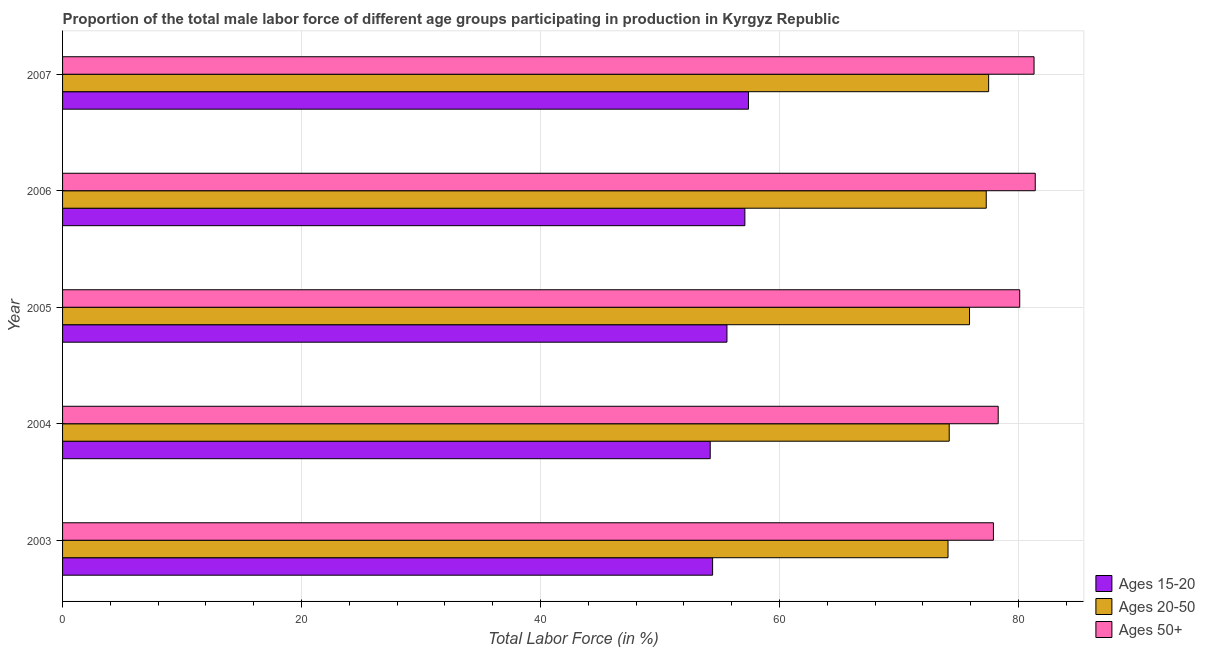How many bars are there on the 3rd tick from the top?
Ensure brevity in your answer.  3. How many bars are there on the 3rd tick from the bottom?
Your answer should be compact. 3. What is the percentage of male labor force within the age group 15-20 in 2007?
Make the answer very short. 57.4. Across all years, what is the maximum percentage of male labor force within the age group 20-50?
Your answer should be very brief. 77.5. Across all years, what is the minimum percentage of male labor force within the age group 20-50?
Offer a terse response. 74.1. In which year was the percentage of male labor force within the age group 20-50 minimum?
Provide a succinct answer. 2003. What is the total percentage of male labor force above age 50 in the graph?
Give a very brief answer. 399. What is the difference between the percentage of male labor force within the age group 20-50 in 2006 and that in 2007?
Offer a terse response. -0.2. What is the difference between the percentage of male labor force within the age group 20-50 in 2006 and the percentage of male labor force within the age group 15-20 in 2003?
Give a very brief answer. 22.9. What is the average percentage of male labor force within the age group 15-20 per year?
Your answer should be compact. 55.74. In the year 2006, what is the difference between the percentage of male labor force within the age group 15-20 and percentage of male labor force within the age group 20-50?
Offer a very short reply. -20.2. In how many years, is the percentage of male labor force within the age group 20-50 greater than 60 %?
Provide a succinct answer. 5. Is the difference between the percentage of male labor force within the age group 20-50 in 2003 and 2007 greater than the difference between the percentage of male labor force above age 50 in 2003 and 2007?
Give a very brief answer. No. What is the difference between the highest and the lowest percentage of male labor force within the age group 20-50?
Give a very brief answer. 3.4. Is the sum of the percentage of male labor force above age 50 in 2006 and 2007 greater than the maximum percentage of male labor force within the age group 20-50 across all years?
Your answer should be compact. Yes. What does the 3rd bar from the top in 2004 represents?
Make the answer very short. Ages 15-20. What does the 1st bar from the bottom in 2005 represents?
Give a very brief answer. Ages 15-20. How many bars are there?
Offer a very short reply. 15. How many years are there in the graph?
Offer a very short reply. 5. Does the graph contain any zero values?
Make the answer very short. No. What is the title of the graph?
Offer a terse response. Proportion of the total male labor force of different age groups participating in production in Kyrgyz Republic. What is the Total Labor Force (in %) in Ages 15-20 in 2003?
Keep it short and to the point. 54.4. What is the Total Labor Force (in %) of Ages 20-50 in 2003?
Provide a short and direct response. 74.1. What is the Total Labor Force (in %) of Ages 50+ in 2003?
Ensure brevity in your answer.  77.9. What is the Total Labor Force (in %) of Ages 15-20 in 2004?
Make the answer very short. 54.2. What is the Total Labor Force (in %) of Ages 20-50 in 2004?
Provide a short and direct response. 74.2. What is the Total Labor Force (in %) of Ages 50+ in 2004?
Give a very brief answer. 78.3. What is the Total Labor Force (in %) of Ages 15-20 in 2005?
Your answer should be very brief. 55.6. What is the Total Labor Force (in %) in Ages 20-50 in 2005?
Keep it short and to the point. 75.9. What is the Total Labor Force (in %) of Ages 50+ in 2005?
Provide a succinct answer. 80.1. What is the Total Labor Force (in %) in Ages 15-20 in 2006?
Make the answer very short. 57.1. What is the Total Labor Force (in %) in Ages 20-50 in 2006?
Give a very brief answer. 77.3. What is the Total Labor Force (in %) of Ages 50+ in 2006?
Provide a short and direct response. 81.4. What is the Total Labor Force (in %) in Ages 15-20 in 2007?
Make the answer very short. 57.4. What is the Total Labor Force (in %) in Ages 20-50 in 2007?
Your response must be concise. 77.5. What is the Total Labor Force (in %) of Ages 50+ in 2007?
Offer a very short reply. 81.3. Across all years, what is the maximum Total Labor Force (in %) of Ages 15-20?
Your answer should be very brief. 57.4. Across all years, what is the maximum Total Labor Force (in %) in Ages 20-50?
Make the answer very short. 77.5. Across all years, what is the maximum Total Labor Force (in %) of Ages 50+?
Ensure brevity in your answer.  81.4. Across all years, what is the minimum Total Labor Force (in %) of Ages 15-20?
Make the answer very short. 54.2. Across all years, what is the minimum Total Labor Force (in %) in Ages 20-50?
Provide a succinct answer. 74.1. Across all years, what is the minimum Total Labor Force (in %) in Ages 50+?
Ensure brevity in your answer.  77.9. What is the total Total Labor Force (in %) in Ages 15-20 in the graph?
Give a very brief answer. 278.7. What is the total Total Labor Force (in %) of Ages 20-50 in the graph?
Ensure brevity in your answer.  379. What is the total Total Labor Force (in %) in Ages 50+ in the graph?
Your answer should be compact. 399. What is the difference between the Total Labor Force (in %) of Ages 20-50 in 2003 and that in 2005?
Give a very brief answer. -1.8. What is the difference between the Total Labor Force (in %) of Ages 20-50 in 2003 and that in 2006?
Your answer should be compact. -3.2. What is the difference between the Total Labor Force (in %) in Ages 20-50 in 2003 and that in 2007?
Offer a terse response. -3.4. What is the difference between the Total Labor Force (in %) of Ages 50+ in 2004 and that in 2005?
Your answer should be very brief. -1.8. What is the difference between the Total Labor Force (in %) of Ages 15-20 in 2004 and that in 2006?
Offer a terse response. -2.9. What is the difference between the Total Labor Force (in %) of Ages 50+ in 2004 and that in 2006?
Offer a terse response. -3.1. What is the difference between the Total Labor Force (in %) of Ages 15-20 in 2005 and that in 2006?
Provide a short and direct response. -1.5. What is the difference between the Total Labor Force (in %) of Ages 20-50 in 2005 and that in 2006?
Your answer should be very brief. -1.4. What is the difference between the Total Labor Force (in %) in Ages 50+ in 2005 and that in 2006?
Keep it short and to the point. -1.3. What is the difference between the Total Labor Force (in %) of Ages 20-50 in 2005 and that in 2007?
Your answer should be very brief. -1.6. What is the difference between the Total Labor Force (in %) in Ages 20-50 in 2006 and that in 2007?
Ensure brevity in your answer.  -0.2. What is the difference between the Total Labor Force (in %) of Ages 15-20 in 2003 and the Total Labor Force (in %) of Ages 20-50 in 2004?
Ensure brevity in your answer.  -19.8. What is the difference between the Total Labor Force (in %) of Ages 15-20 in 2003 and the Total Labor Force (in %) of Ages 50+ in 2004?
Your response must be concise. -23.9. What is the difference between the Total Labor Force (in %) of Ages 20-50 in 2003 and the Total Labor Force (in %) of Ages 50+ in 2004?
Offer a terse response. -4.2. What is the difference between the Total Labor Force (in %) in Ages 15-20 in 2003 and the Total Labor Force (in %) in Ages 20-50 in 2005?
Ensure brevity in your answer.  -21.5. What is the difference between the Total Labor Force (in %) in Ages 15-20 in 2003 and the Total Labor Force (in %) in Ages 50+ in 2005?
Keep it short and to the point. -25.7. What is the difference between the Total Labor Force (in %) in Ages 20-50 in 2003 and the Total Labor Force (in %) in Ages 50+ in 2005?
Ensure brevity in your answer.  -6. What is the difference between the Total Labor Force (in %) of Ages 15-20 in 2003 and the Total Labor Force (in %) of Ages 20-50 in 2006?
Make the answer very short. -22.9. What is the difference between the Total Labor Force (in %) of Ages 15-20 in 2003 and the Total Labor Force (in %) of Ages 20-50 in 2007?
Your response must be concise. -23.1. What is the difference between the Total Labor Force (in %) of Ages 15-20 in 2003 and the Total Labor Force (in %) of Ages 50+ in 2007?
Provide a succinct answer. -26.9. What is the difference between the Total Labor Force (in %) in Ages 20-50 in 2003 and the Total Labor Force (in %) in Ages 50+ in 2007?
Provide a short and direct response. -7.2. What is the difference between the Total Labor Force (in %) in Ages 15-20 in 2004 and the Total Labor Force (in %) in Ages 20-50 in 2005?
Ensure brevity in your answer.  -21.7. What is the difference between the Total Labor Force (in %) of Ages 15-20 in 2004 and the Total Labor Force (in %) of Ages 50+ in 2005?
Ensure brevity in your answer.  -25.9. What is the difference between the Total Labor Force (in %) of Ages 15-20 in 2004 and the Total Labor Force (in %) of Ages 20-50 in 2006?
Your response must be concise. -23.1. What is the difference between the Total Labor Force (in %) of Ages 15-20 in 2004 and the Total Labor Force (in %) of Ages 50+ in 2006?
Your answer should be compact. -27.2. What is the difference between the Total Labor Force (in %) in Ages 20-50 in 2004 and the Total Labor Force (in %) in Ages 50+ in 2006?
Give a very brief answer. -7.2. What is the difference between the Total Labor Force (in %) in Ages 15-20 in 2004 and the Total Labor Force (in %) in Ages 20-50 in 2007?
Offer a very short reply. -23.3. What is the difference between the Total Labor Force (in %) of Ages 15-20 in 2004 and the Total Labor Force (in %) of Ages 50+ in 2007?
Ensure brevity in your answer.  -27.1. What is the difference between the Total Labor Force (in %) in Ages 15-20 in 2005 and the Total Labor Force (in %) in Ages 20-50 in 2006?
Provide a short and direct response. -21.7. What is the difference between the Total Labor Force (in %) of Ages 15-20 in 2005 and the Total Labor Force (in %) of Ages 50+ in 2006?
Provide a succinct answer. -25.8. What is the difference between the Total Labor Force (in %) of Ages 20-50 in 2005 and the Total Labor Force (in %) of Ages 50+ in 2006?
Your answer should be compact. -5.5. What is the difference between the Total Labor Force (in %) in Ages 15-20 in 2005 and the Total Labor Force (in %) in Ages 20-50 in 2007?
Provide a short and direct response. -21.9. What is the difference between the Total Labor Force (in %) in Ages 15-20 in 2005 and the Total Labor Force (in %) in Ages 50+ in 2007?
Your answer should be compact. -25.7. What is the difference between the Total Labor Force (in %) in Ages 15-20 in 2006 and the Total Labor Force (in %) in Ages 20-50 in 2007?
Offer a very short reply. -20.4. What is the difference between the Total Labor Force (in %) in Ages 15-20 in 2006 and the Total Labor Force (in %) in Ages 50+ in 2007?
Your answer should be compact. -24.2. What is the difference between the Total Labor Force (in %) of Ages 20-50 in 2006 and the Total Labor Force (in %) of Ages 50+ in 2007?
Provide a short and direct response. -4. What is the average Total Labor Force (in %) in Ages 15-20 per year?
Provide a succinct answer. 55.74. What is the average Total Labor Force (in %) of Ages 20-50 per year?
Ensure brevity in your answer.  75.8. What is the average Total Labor Force (in %) of Ages 50+ per year?
Your answer should be very brief. 79.8. In the year 2003, what is the difference between the Total Labor Force (in %) in Ages 15-20 and Total Labor Force (in %) in Ages 20-50?
Provide a succinct answer. -19.7. In the year 2003, what is the difference between the Total Labor Force (in %) in Ages 15-20 and Total Labor Force (in %) in Ages 50+?
Offer a very short reply. -23.5. In the year 2004, what is the difference between the Total Labor Force (in %) in Ages 15-20 and Total Labor Force (in %) in Ages 20-50?
Make the answer very short. -20. In the year 2004, what is the difference between the Total Labor Force (in %) in Ages 15-20 and Total Labor Force (in %) in Ages 50+?
Your answer should be very brief. -24.1. In the year 2005, what is the difference between the Total Labor Force (in %) in Ages 15-20 and Total Labor Force (in %) in Ages 20-50?
Your answer should be very brief. -20.3. In the year 2005, what is the difference between the Total Labor Force (in %) of Ages 15-20 and Total Labor Force (in %) of Ages 50+?
Ensure brevity in your answer.  -24.5. In the year 2006, what is the difference between the Total Labor Force (in %) of Ages 15-20 and Total Labor Force (in %) of Ages 20-50?
Ensure brevity in your answer.  -20.2. In the year 2006, what is the difference between the Total Labor Force (in %) of Ages 15-20 and Total Labor Force (in %) of Ages 50+?
Your answer should be compact. -24.3. In the year 2006, what is the difference between the Total Labor Force (in %) in Ages 20-50 and Total Labor Force (in %) in Ages 50+?
Ensure brevity in your answer.  -4.1. In the year 2007, what is the difference between the Total Labor Force (in %) in Ages 15-20 and Total Labor Force (in %) in Ages 20-50?
Provide a succinct answer. -20.1. In the year 2007, what is the difference between the Total Labor Force (in %) of Ages 15-20 and Total Labor Force (in %) of Ages 50+?
Your response must be concise. -23.9. What is the ratio of the Total Labor Force (in %) of Ages 15-20 in 2003 to that in 2005?
Your answer should be compact. 0.98. What is the ratio of the Total Labor Force (in %) in Ages 20-50 in 2003 to that in 2005?
Offer a terse response. 0.98. What is the ratio of the Total Labor Force (in %) of Ages 50+ in 2003 to that in 2005?
Your answer should be very brief. 0.97. What is the ratio of the Total Labor Force (in %) in Ages 15-20 in 2003 to that in 2006?
Your answer should be compact. 0.95. What is the ratio of the Total Labor Force (in %) in Ages 20-50 in 2003 to that in 2006?
Make the answer very short. 0.96. What is the ratio of the Total Labor Force (in %) of Ages 15-20 in 2003 to that in 2007?
Offer a terse response. 0.95. What is the ratio of the Total Labor Force (in %) in Ages 20-50 in 2003 to that in 2007?
Provide a short and direct response. 0.96. What is the ratio of the Total Labor Force (in %) of Ages 50+ in 2003 to that in 2007?
Keep it short and to the point. 0.96. What is the ratio of the Total Labor Force (in %) of Ages 15-20 in 2004 to that in 2005?
Provide a short and direct response. 0.97. What is the ratio of the Total Labor Force (in %) of Ages 20-50 in 2004 to that in 2005?
Provide a succinct answer. 0.98. What is the ratio of the Total Labor Force (in %) of Ages 50+ in 2004 to that in 2005?
Make the answer very short. 0.98. What is the ratio of the Total Labor Force (in %) of Ages 15-20 in 2004 to that in 2006?
Offer a very short reply. 0.95. What is the ratio of the Total Labor Force (in %) of Ages 20-50 in 2004 to that in 2006?
Your response must be concise. 0.96. What is the ratio of the Total Labor Force (in %) of Ages 50+ in 2004 to that in 2006?
Your answer should be very brief. 0.96. What is the ratio of the Total Labor Force (in %) of Ages 15-20 in 2004 to that in 2007?
Keep it short and to the point. 0.94. What is the ratio of the Total Labor Force (in %) of Ages 20-50 in 2004 to that in 2007?
Provide a short and direct response. 0.96. What is the ratio of the Total Labor Force (in %) in Ages 50+ in 2004 to that in 2007?
Give a very brief answer. 0.96. What is the ratio of the Total Labor Force (in %) in Ages 15-20 in 2005 to that in 2006?
Your answer should be very brief. 0.97. What is the ratio of the Total Labor Force (in %) in Ages 20-50 in 2005 to that in 2006?
Keep it short and to the point. 0.98. What is the ratio of the Total Labor Force (in %) in Ages 15-20 in 2005 to that in 2007?
Offer a very short reply. 0.97. What is the ratio of the Total Labor Force (in %) of Ages 20-50 in 2005 to that in 2007?
Your response must be concise. 0.98. What is the ratio of the Total Labor Force (in %) in Ages 50+ in 2005 to that in 2007?
Offer a terse response. 0.99. What is the difference between the highest and the second highest Total Labor Force (in %) of Ages 50+?
Offer a terse response. 0.1. What is the difference between the highest and the lowest Total Labor Force (in %) of Ages 15-20?
Make the answer very short. 3.2. What is the difference between the highest and the lowest Total Labor Force (in %) in Ages 20-50?
Your answer should be compact. 3.4. What is the difference between the highest and the lowest Total Labor Force (in %) in Ages 50+?
Provide a succinct answer. 3.5. 